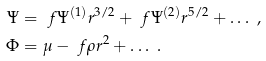Convert formula to latex. <formula><loc_0><loc_0><loc_500><loc_500>\Psi & = \ f { \Psi ^ { ( 1 ) } } { r ^ { 3 / 2 } } + \ f { \Psi ^ { ( 2 ) } } { r ^ { 5 / 2 } } + \dots \ , \\ \Phi & = \mu - \ f { \rho } { r ^ { 2 } } + \dots \ .</formula> 